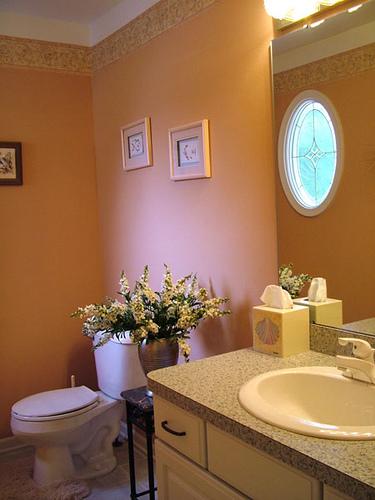Why is this bathroom so clean?
Short answer required. It was just cleaned. What shape is the window?
Concise answer only. Round. Do those flowers smell good?
Answer briefly. Yes. 